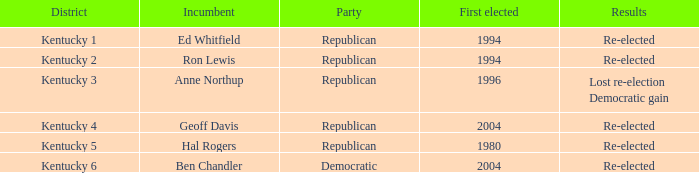In what year did the kentucky 2nd district's republican incumbent first get elected? 1994.0. 